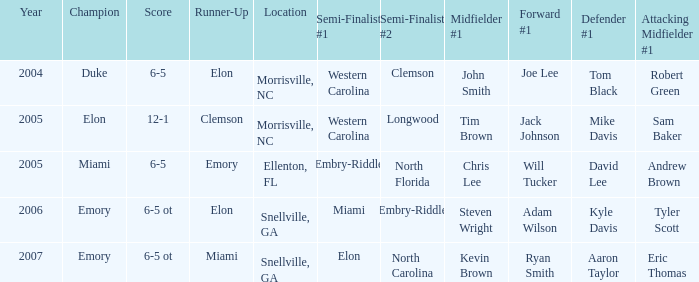How many teams were listed as runner up in 2005 and there the first semi finalist was Western Carolina? 1.0. 